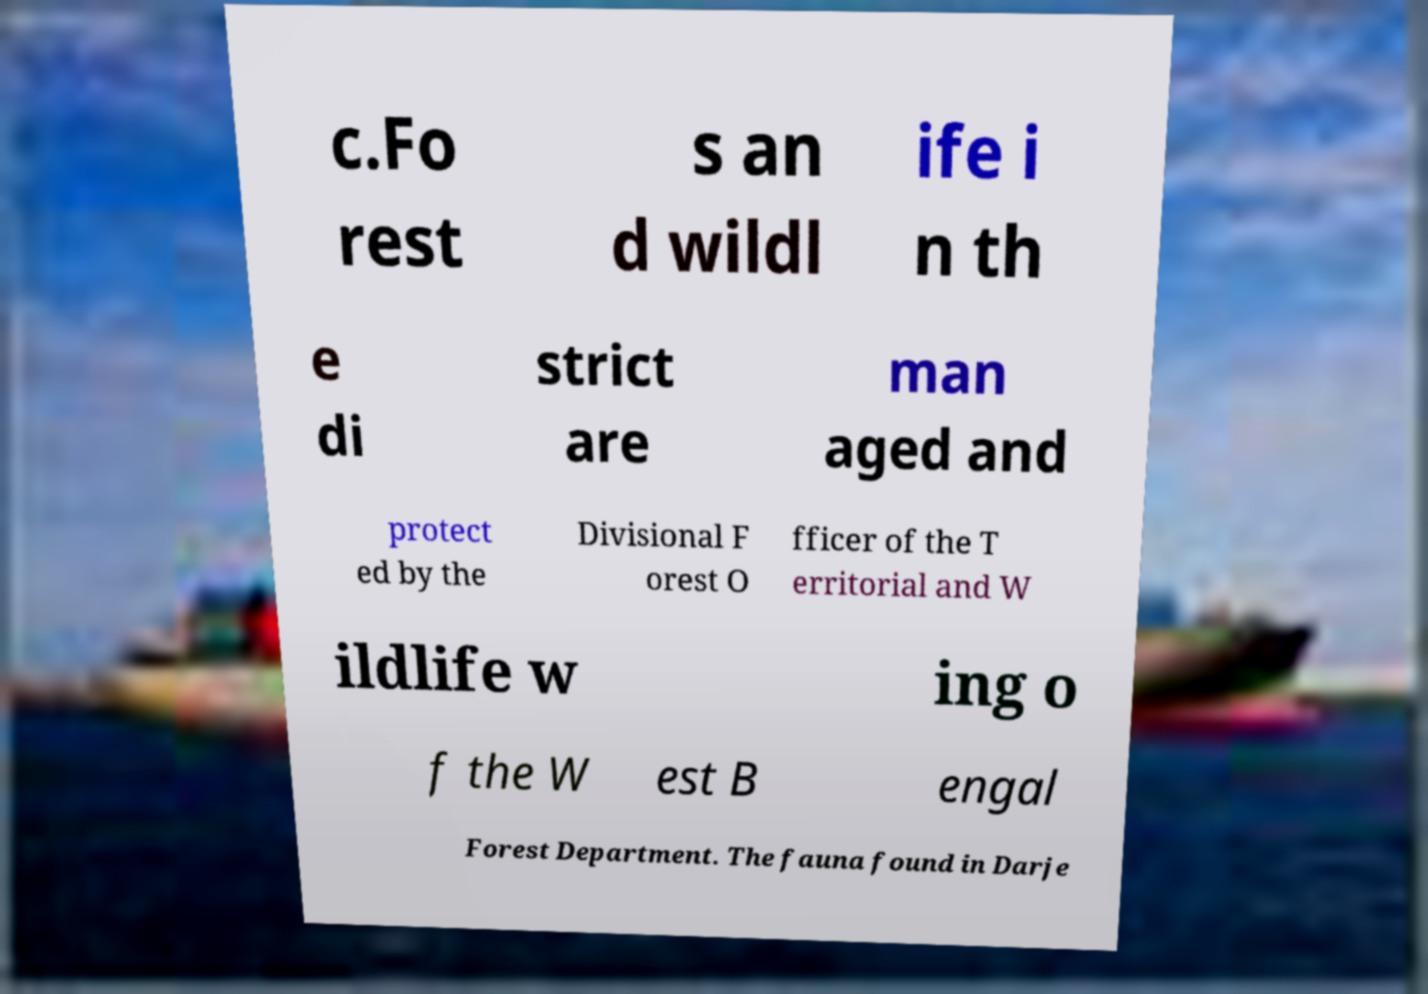Can you read and provide the text displayed in the image?This photo seems to have some interesting text. Can you extract and type it out for me? c.Fo rest s an d wildl ife i n th e di strict are man aged and protect ed by the Divisional F orest O fficer of the T erritorial and W ildlife w ing o f the W est B engal Forest Department. The fauna found in Darje 